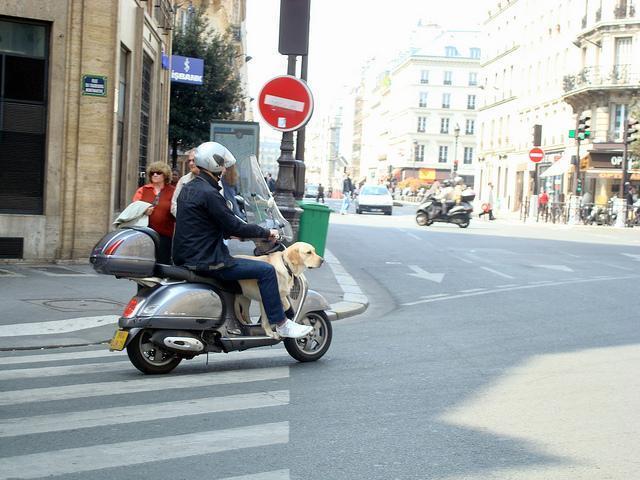How many people are visible?
Give a very brief answer. 2. How many carrots are there?
Give a very brief answer. 0. 